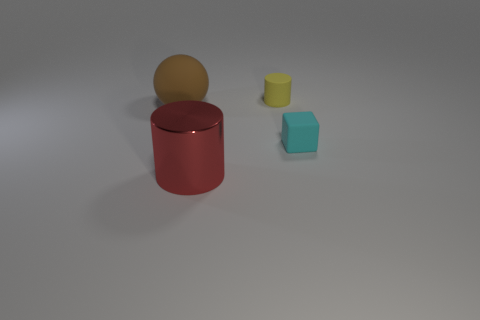Add 3 big purple balls. How many objects exist? 7 Subtract all spheres. How many objects are left? 3 Add 2 small cyan matte blocks. How many small cyan matte blocks exist? 3 Subtract 0 gray cubes. How many objects are left? 4 Subtract all brown things. Subtract all red things. How many objects are left? 2 Add 4 tiny yellow matte things. How many tiny yellow matte things are left? 5 